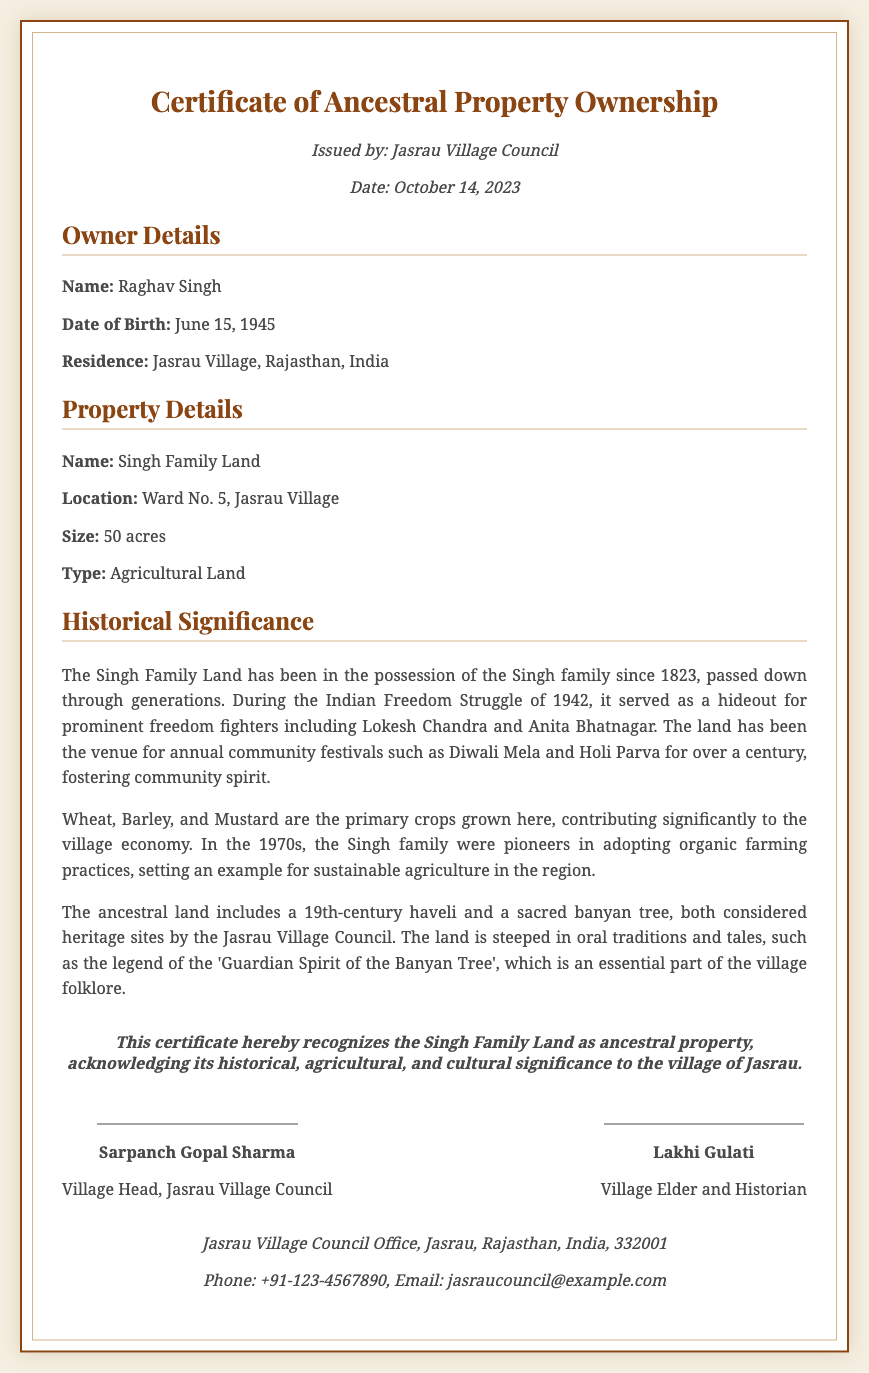what is the name of the property? The name of the property is mentioned for ownership verification as "Singh Family Land."
Answer: Singh Family Land who issued the certificate? The certificate is issued by the governing body of the village, which is specified in the document.
Answer: Jasrau Village Council what is the size of the property? The size of the property is explicitly stated in the document as the measurement of land area owned.
Answer: 50 acres when was the property first possessed by the family? The document states the year the land has been in the possession of the Singh family since its inception.
Answer: 1823 what types of crops are primarily grown on the land? The main crops cultivated on the property are specifically listed, highlighting the agricultural focus of the land.
Answer: Wheat, Barley, Mustard who are the prominent historical figures associated with the property during the freedom struggle? The document mentions significant historical personalities who utilized the property as a refuge during a crucial time in Indian history.
Answer: Lokesh Chandra, Anita Bhatnagar what significant practices did the Singh family introduce in the 1970s? The document highlights the family's contribution to innovative farming techniques, showcasing a shift in agriculture.
Answer: Organic farming what is the historical significance of the banyan tree mentioned? The document describes the banyan tree as a crucial cultural symbol within the village, reflecting its historical relevance.
Answer: Guardian Spirit of the Banyan Tree 